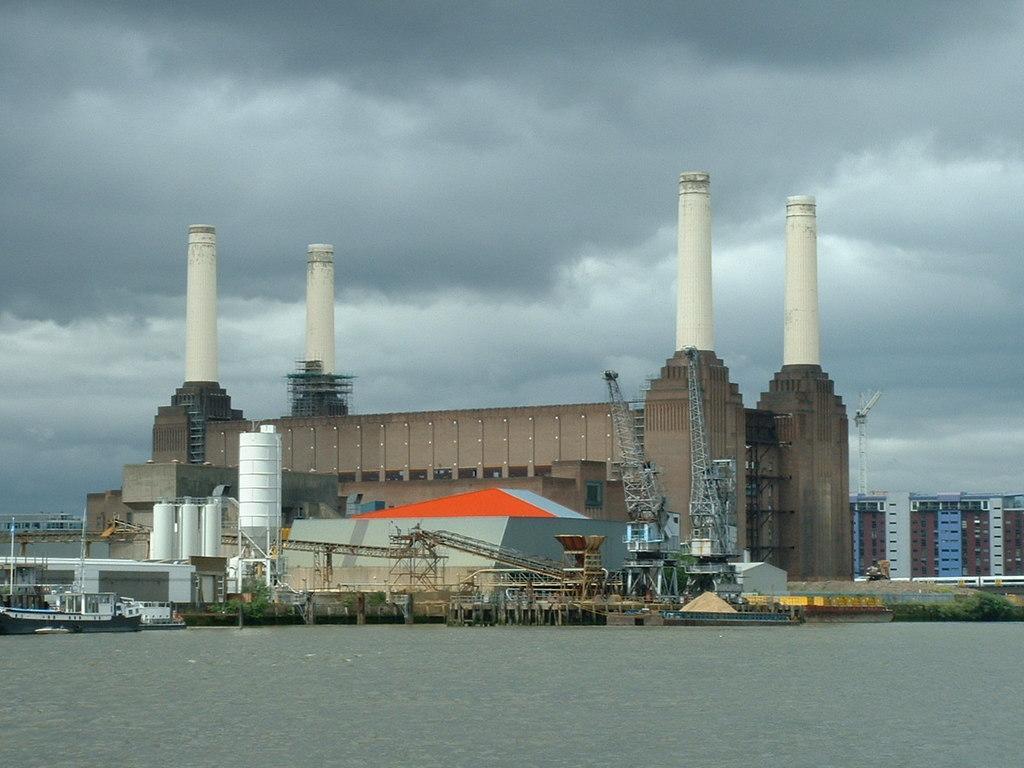Please provide a concise description of this image. In this image there is the sky towards the top of the image, there are clouds in the sky, there are buildings, there are towers, there are objects on the ground, there are plants towards the right of the image, there is water towards the bottom of the image. 